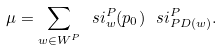Convert formula to latex. <formula><loc_0><loc_0><loc_500><loc_500>\mu = \sum _ { w \in W ^ { P } } \ s i ^ { P } _ { w } ( p _ { 0 } ) \, \ s i ^ { P } _ { P D ( w ) } .</formula> 